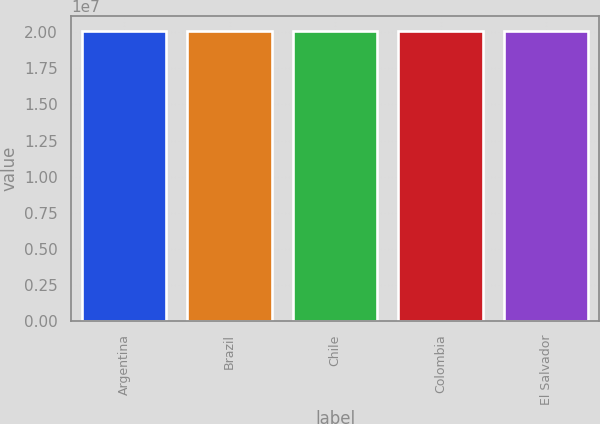<chart> <loc_0><loc_0><loc_500><loc_500><bar_chart><fcel>Argentina<fcel>Brazil<fcel>Chile<fcel>Colombia<fcel>El Salvador<nl><fcel>2.0062e+07<fcel>2.0082e+07<fcel>2.0092e+07<fcel>2.0112e+07<fcel>2.0102e+07<nl></chart> 